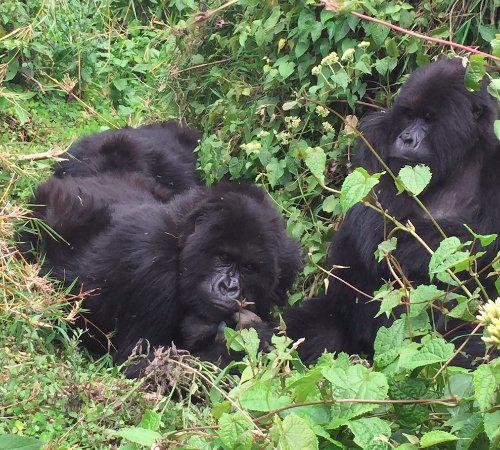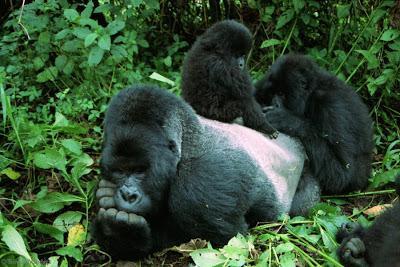The first image is the image on the left, the second image is the image on the right. Evaluate the accuracy of this statement regarding the images: "The gorilla in the foreground of the right image has both its hands at mouth level, with fingers curled.". Is it true? Answer yes or no. Yes. The first image is the image on the left, the second image is the image on the right. Analyze the images presented: Is the assertion "There is a group of gorillas in both images." valid? Answer yes or no. Yes. 